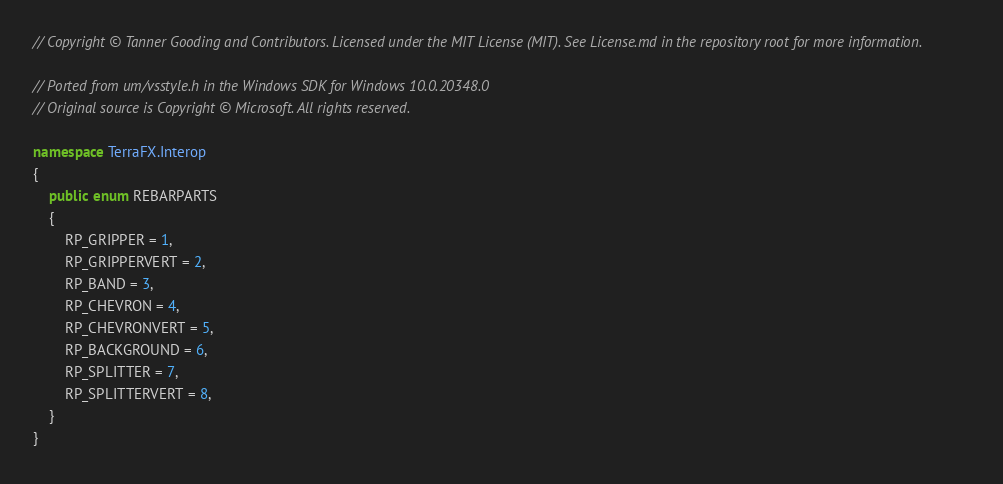Convert code to text. <code><loc_0><loc_0><loc_500><loc_500><_C#_>// Copyright © Tanner Gooding and Contributors. Licensed under the MIT License (MIT). See License.md in the repository root for more information.

// Ported from um/vsstyle.h in the Windows SDK for Windows 10.0.20348.0
// Original source is Copyright © Microsoft. All rights reserved.

namespace TerraFX.Interop
{
    public enum REBARPARTS
    {
        RP_GRIPPER = 1,
        RP_GRIPPERVERT = 2,
        RP_BAND = 3,
        RP_CHEVRON = 4,
        RP_CHEVRONVERT = 5,
        RP_BACKGROUND = 6,
        RP_SPLITTER = 7,
        RP_SPLITTERVERT = 8,
    }
}
</code> 